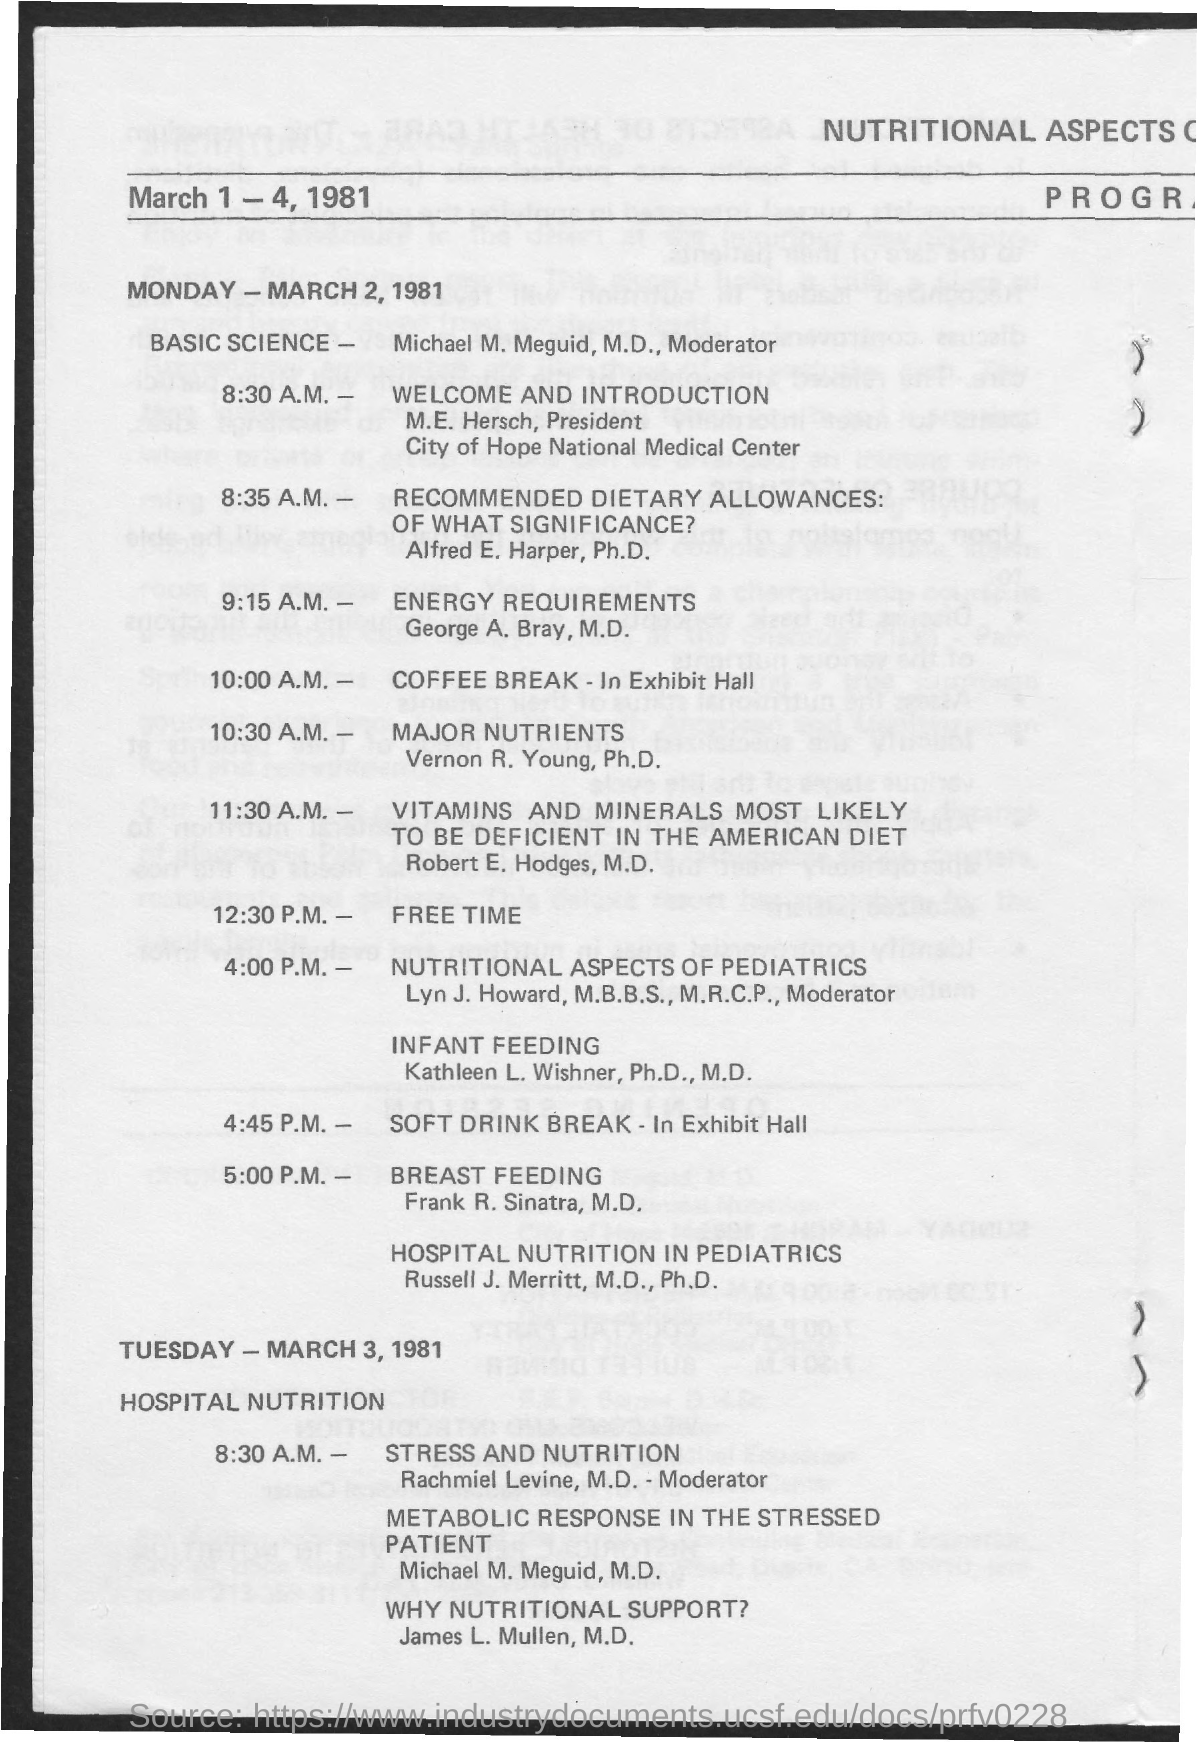Give some essential details in this illustration. The session after the coffee break will focus on the major nutrients. The president of the City of Hope National Medical Center is M.E. Hersch. The coffee break will take place at 10:00 a.m. 